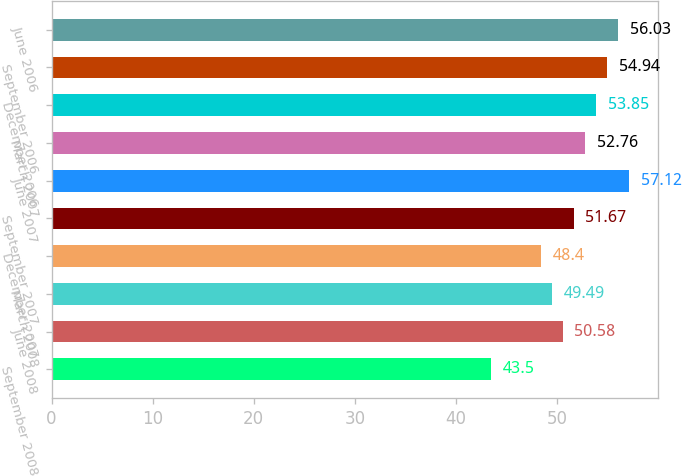<chart> <loc_0><loc_0><loc_500><loc_500><bar_chart><fcel>September 2008<fcel>June 2008<fcel>March 2008<fcel>December 2007<fcel>September 2007<fcel>June 2007<fcel>March 2007<fcel>December 2006<fcel>September 2006<fcel>June 2006<nl><fcel>43.5<fcel>50.58<fcel>49.49<fcel>48.4<fcel>51.67<fcel>57.12<fcel>52.76<fcel>53.85<fcel>54.94<fcel>56.03<nl></chart> 